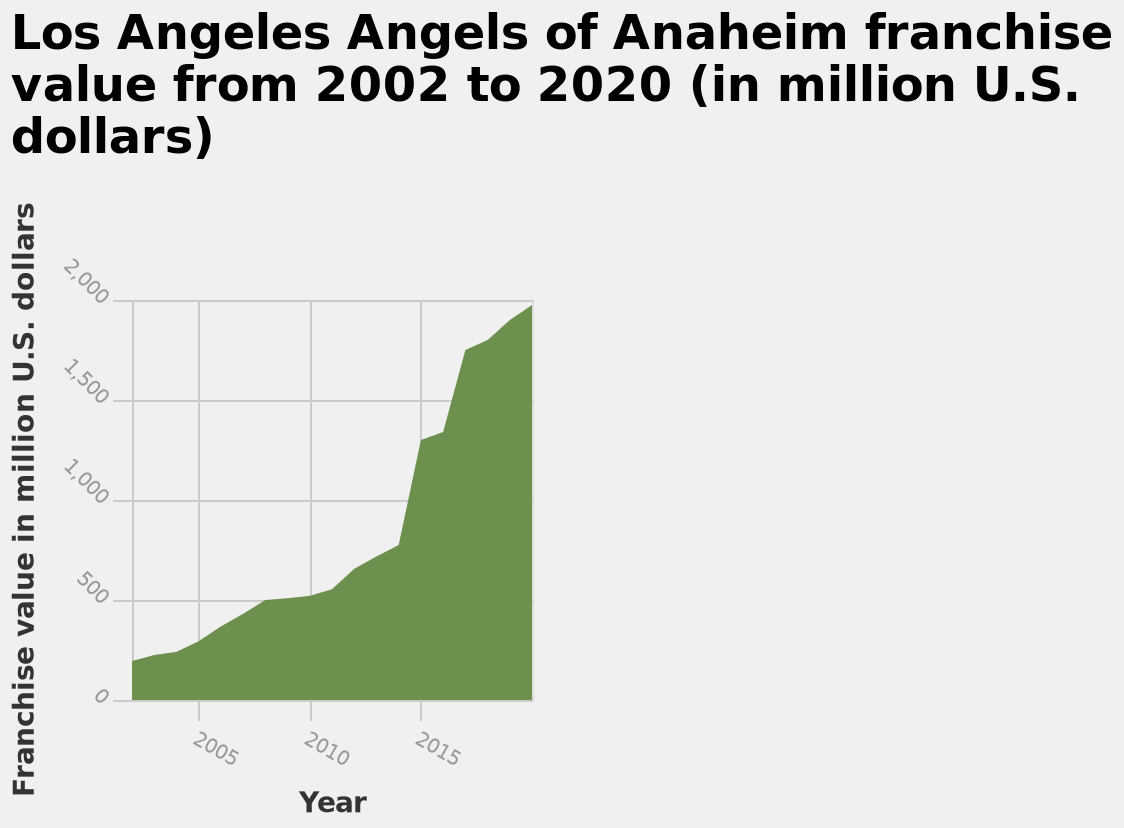<image>
What is the relationship between the years and the value of the franchise? There is a direct correlation between the years and the value of the franchise, where the value increases as the years increase. What is the unit used for the franchise value on the y-axis? The unit used for the franchise value on the y-axis is million U.S. dollars. What does the area plot represent? The area plot represents the franchise value of the Los Angeles Angels of Anaheim from 2002 to 2020 in million U.S. dollars. In which currency is the value of the franchise measured?  The value of the franchise is measured in US dollars. 